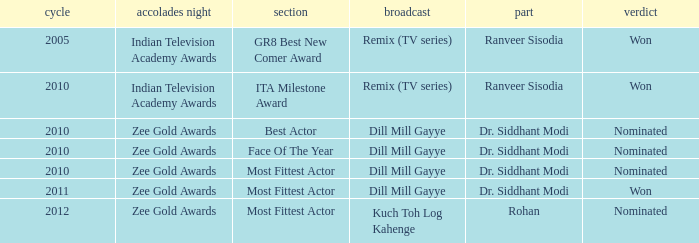Which character was nominated in the 2010 Indian Television Academy Awards? Ranveer Sisodia. 